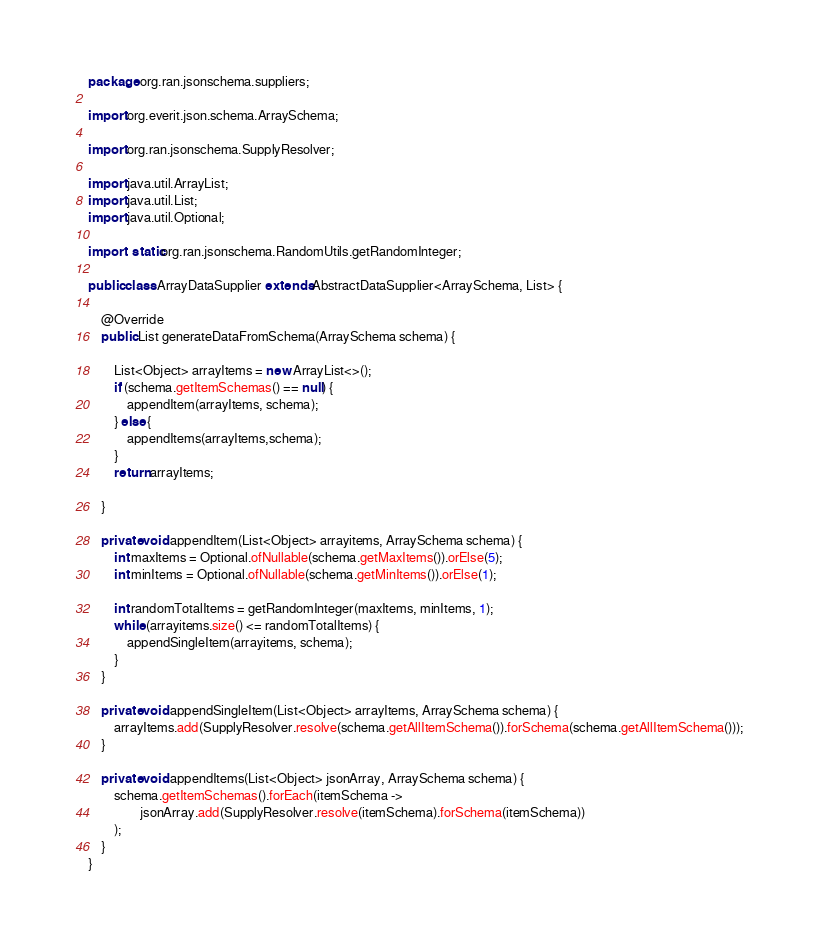Convert code to text. <code><loc_0><loc_0><loc_500><loc_500><_Java_>package org.ran.jsonschema.suppliers;

import org.everit.json.schema.ArraySchema;

import org.ran.jsonschema.SupplyResolver;

import java.util.ArrayList;
import java.util.List;
import java.util.Optional;

import static org.ran.jsonschema.RandomUtils.getRandomInteger;

public class ArrayDataSupplier extends AbstractDataSupplier<ArraySchema, List> {

    @Override
    public List generateDataFromSchema(ArraySchema schema) {

        List<Object> arrayItems = new ArrayList<>();
        if (schema.getItemSchemas() == null) {
            appendItem(arrayItems, schema);
        } else {
            appendItems(arrayItems,schema);
        }
        return arrayItems;

    }

    private void appendItem(List<Object> arrayitems, ArraySchema schema) {
        int maxItems = Optional.ofNullable(schema.getMaxItems()).orElse(5);
        int minItems = Optional.ofNullable(schema.getMinItems()).orElse(1);

        int randomTotalItems = getRandomInteger(maxItems, minItems, 1);
        while (arrayitems.size() <= randomTotalItems) {
            appendSingleItem(arrayitems, schema);
        }
    }

    private void appendSingleItem(List<Object> arrayItems, ArraySchema schema) {
        arrayItems.add(SupplyResolver.resolve(schema.getAllItemSchema()).forSchema(schema.getAllItemSchema()));
    }

    private void appendItems(List<Object> jsonArray, ArraySchema schema) {
        schema.getItemSchemas().forEach(itemSchema ->
                jsonArray.add(SupplyResolver.resolve(itemSchema).forSchema(itemSchema))
        );
    }
}
</code> 